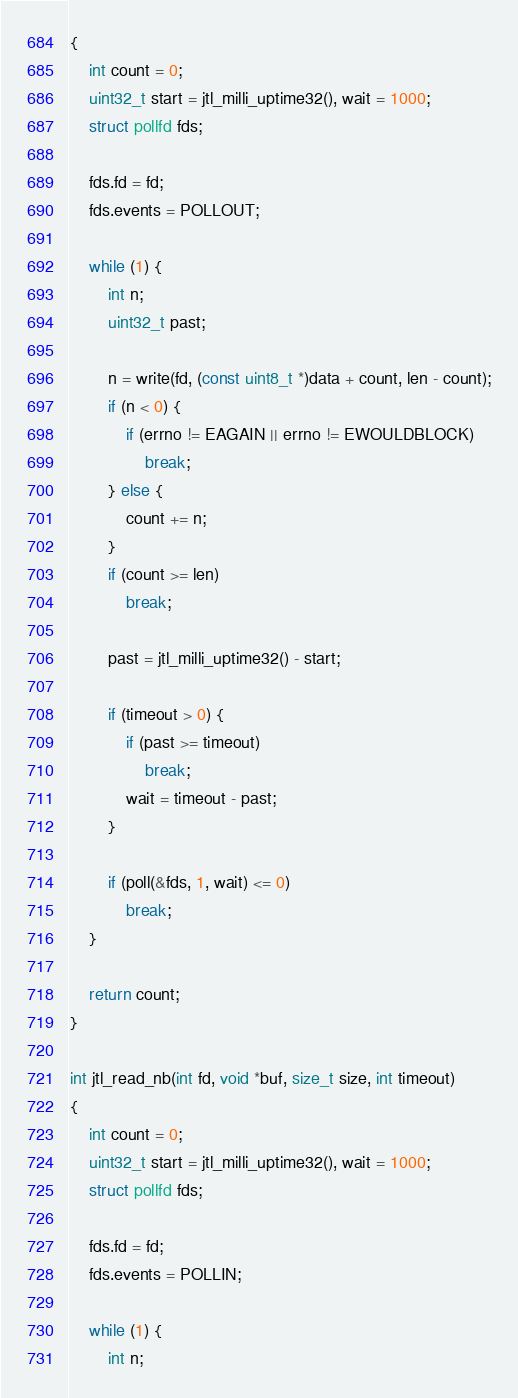<code> <loc_0><loc_0><loc_500><loc_500><_C_>{
	int count = 0;
	uint32_t start = jtl_milli_uptime32(), wait = 1000;
	struct pollfd fds;

	fds.fd = fd;
	fds.events = POLLOUT;

	while (1) {
		int n;
		uint32_t past;

		n = write(fd, (const uint8_t *)data + count, len - count);
		if (n < 0) {
			if (errno != EAGAIN || errno != EWOULDBLOCK)
				break;
		} else {
			count += n;
		}
		if (count >= len)
			break;

		past = jtl_milli_uptime32() - start;

		if (timeout > 0) {
			if (past >= timeout)
				break;
			wait = timeout - past;
		}

		if (poll(&fds, 1, wait) <= 0)
			break;
	}

	return count;
}

int jtl_read_nb(int fd, void *buf, size_t size, int timeout)
{
	int count = 0;
	uint32_t start = jtl_milli_uptime32(), wait = 1000;
	struct pollfd fds;

	fds.fd = fd;
	fds.events = POLLIN;

	while (1) {
		int n;</code> 